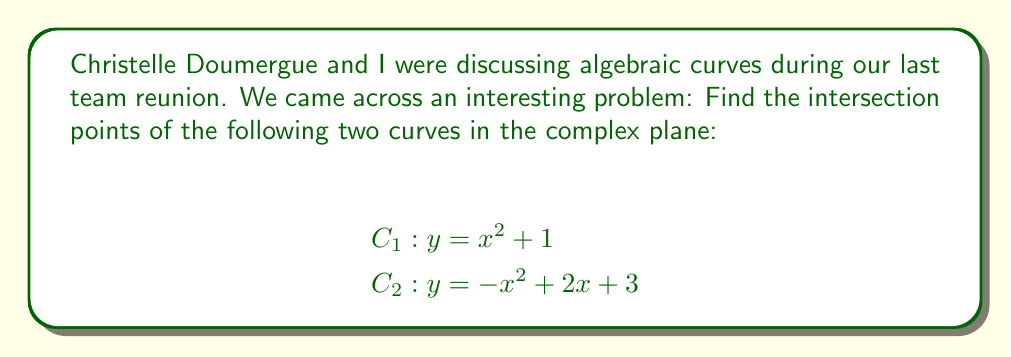Give your solution to this math problem. To find the intersection points of these two curves, we need to solve the system of equations:

$$\begin{cases}
y = x^2 + 1 \\
y = -x^2 + 2x + 3
\end{cases}$$

Step 1: Set the two equations equal to each other.
$x^2 + 1 = -x^2 + 2x + 3$

Step 2: Rearrange the equation to standard form.
$2x^2 - 2x - 2 = 0$

Step 3: Simplify by dividing all terms by 2.
$x^2 - x - 1 = 0$

Step 4: Use the quadratic formula to solve for x.
$x = \frac{-b \pm \sqrt{b^2 - 4ac}}{2a}$

Where $a=1$, $b=-1$, and $c=-1$

$x = \frac{1 \pm \sqrt{1 - 4(1)(-1)}}{2(1)} = \frac{1 \pm \sqrt{5}}{2}$

Step 5: Calculate the y-coordinates by substituting the x-values into either of the original equations. Let's use $y = x^2 + 1$.

For $x = \frac{1 + \sqrt{5}}{2}$:
$y = (\frac{1 + \sqrt{5}}{2})^2 + 1 = \frac{3 + \sqrt{5}}{2}$

For $x = \frac{1 - \sqrt{5}}{2}$:
$y = (\frac{1 - \sqrt{5}}{2})^2 + 1 = \frac{3 - \sqrt{5}}{2}$

Therefore, the intersection points are:
$(\frac{1 + \sqrt{5}}{2}, \frac{3 + \sqrt{5}}{2})$ and $(\frac{1 - \sqrt{5}}{2}, \frac{3 - \sqrt{5}}{2})$
Answer: $(\frac{1 + \sqrt{5}}{2}, \frac{3 + \sqrt{5}}{2})$ and $(\frac{1 - \sqrt{5}}{2}, \frac{3 - \sqrt{5}}{2})$ 